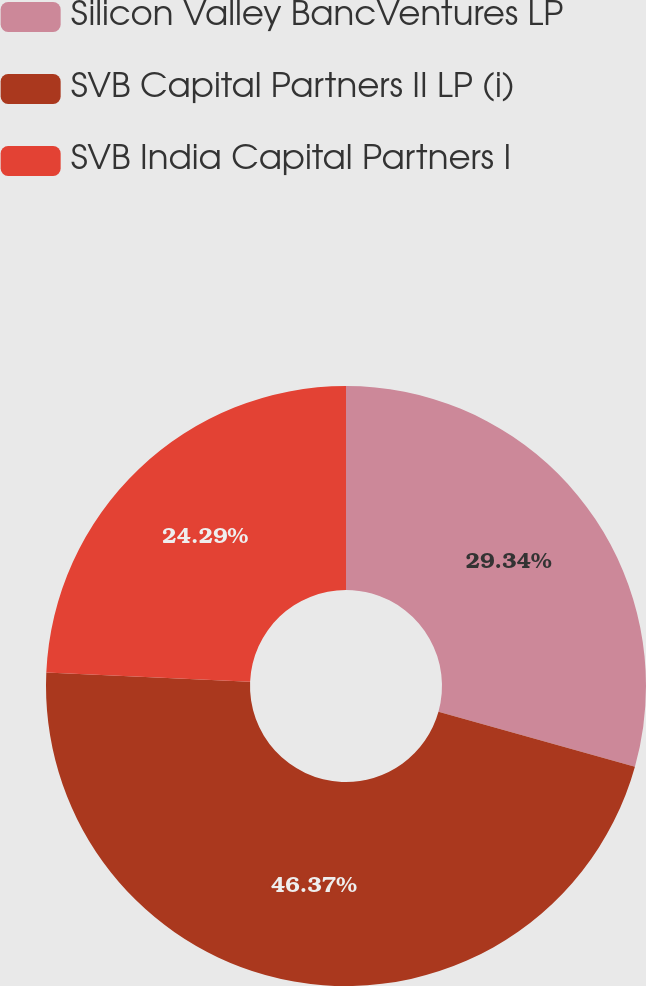Convert chart to OTSL. <chart><loc_0><loc_0><loc_500><loc_500><pie_chart><fcel>Silicon Valley BancVentures LP<fcel>SVB Capital Partners II LP (i)<fcel>SVB India Capital Partners I<nl><fcel>29.34%<fcel>46.38%<fcel>24.29%<nl></chart> 